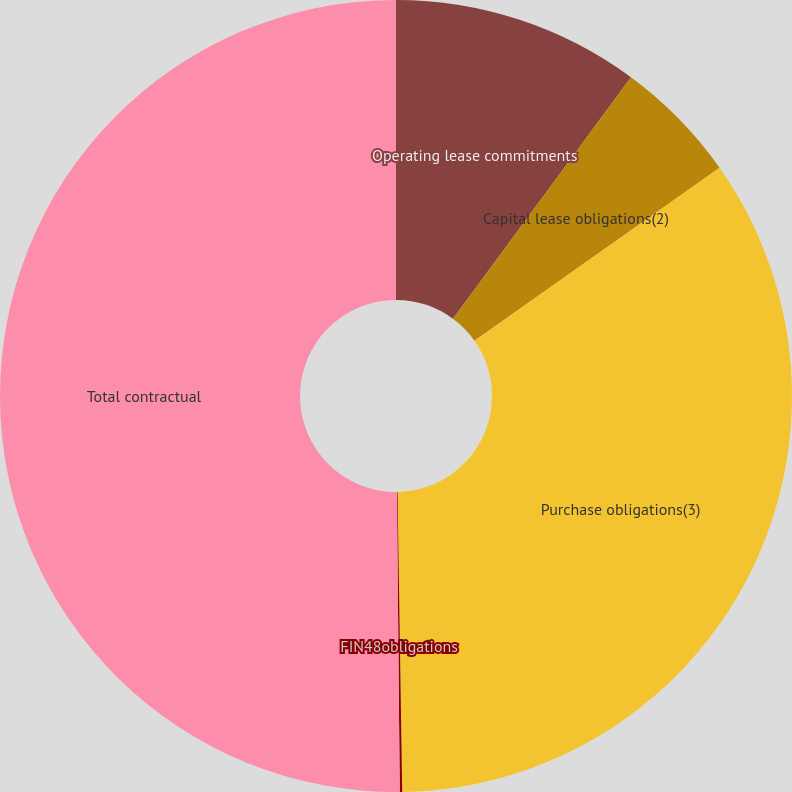<chart> <loc_0><loc_0><loc_500><loc_500><pie_chart><fcel>Operating lease commitments<fcel>Capital lease obligations(2)<fcel>Purchase obligations(3)<fcel>FIN48obligations<fcel>Total contractual<nl><fcel>10.11%<fcel>5.11%<fcel>34.53%<fcel>0.1%<fcel>50.15%<nl></chart> 